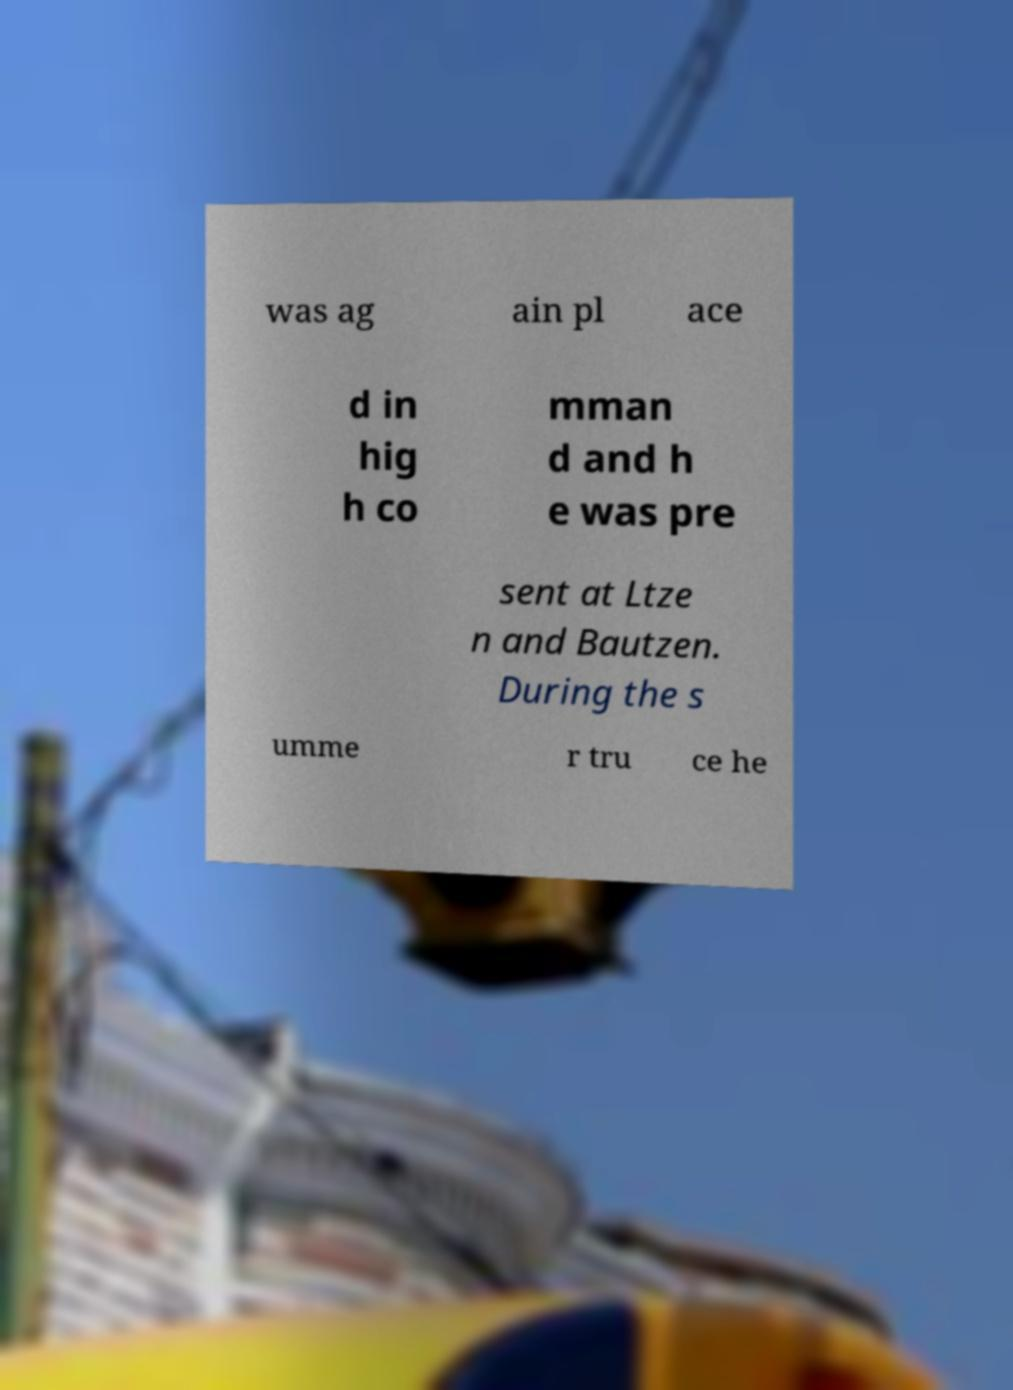Please read and relay the text visible in this image. What does it say? was ag ain pl ace d in hig h co mman d and h e was pre sent at Ltze n and Bautzen. During the s umme r tru ce he 